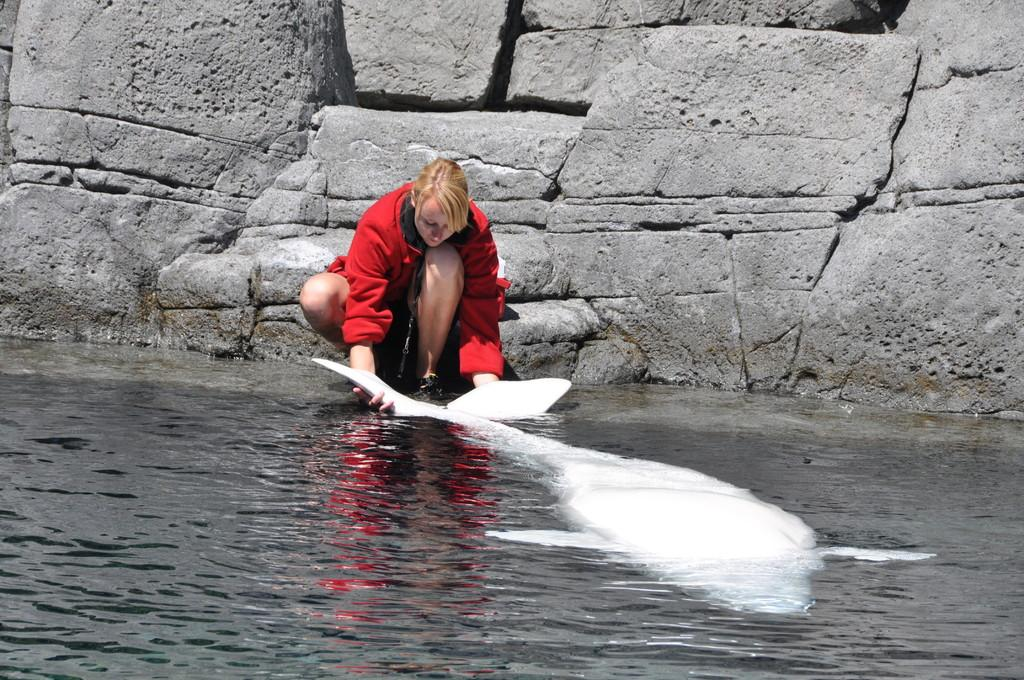Who is the main subject in the image? There is a woman in the image. What is the woman holding in the image? The woman is holding a white-colored dolphin. Where is the dolphin located in the image? The dolphin is in the water. What can be seen in the background of the image? There is a stone wall in the background of the image. What is the woman wearing in the image? The woman is wearing a red dress. What type of dolls is the woman's aunt collecting in the image? There is no mention of dolls or the woman's aunt in the image, so it cannot be determined from the image. 